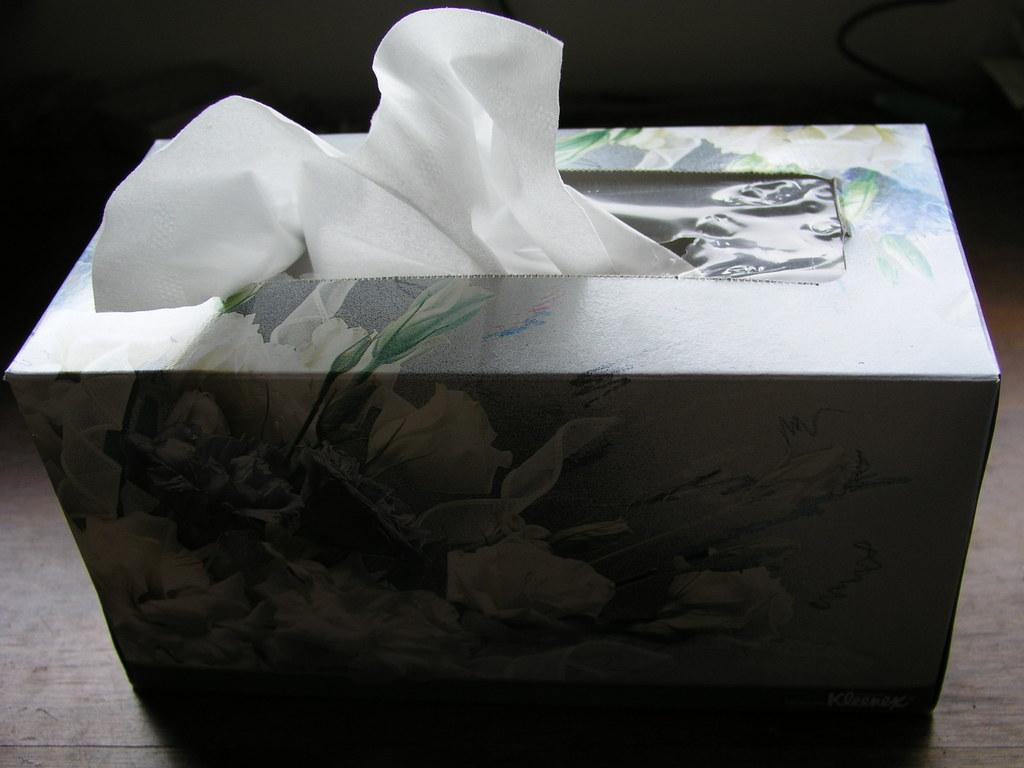What object can be seen in the image related to tissues? There is a tissue holder in the image. Where is the tissue holder located? The tissue holder is placed on the floor. What type of boat is visible in the image? There is no boat present in the image; it only features a tissue holder placed on the floor. What arithmetic problem can be solved using the tissue holder in the image? The tissue holder is not related to arithmetic, so no problem can be solved using it. 